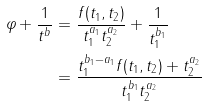<formula> <loc_0><loc_0><loc_500><loc_500>\varphi + \frac { 1 } { t ^ { b } } & = \frac { f ( t _ { 1 } , t _ { 2 } ) } { t _ { 1 } ^ { a _ { 1 } } t _ { 2 } ^ { a _ { 2 } } } + \frac { 1 } { t _ { 1 } ^ { b _ { 1 } } } \\ & = \frac { t _ { 1 } ^ { b _ { 1 } - a _ { 1 } } f ( t _ { 1 } , t _ { 2 } ) + t _ { 2 } ^ { a _ { 2 } } } { t _ { 1 } ^ { b _ { 1 } } t _ { 2 } ^ { a _ { 2 } } }</formula> 